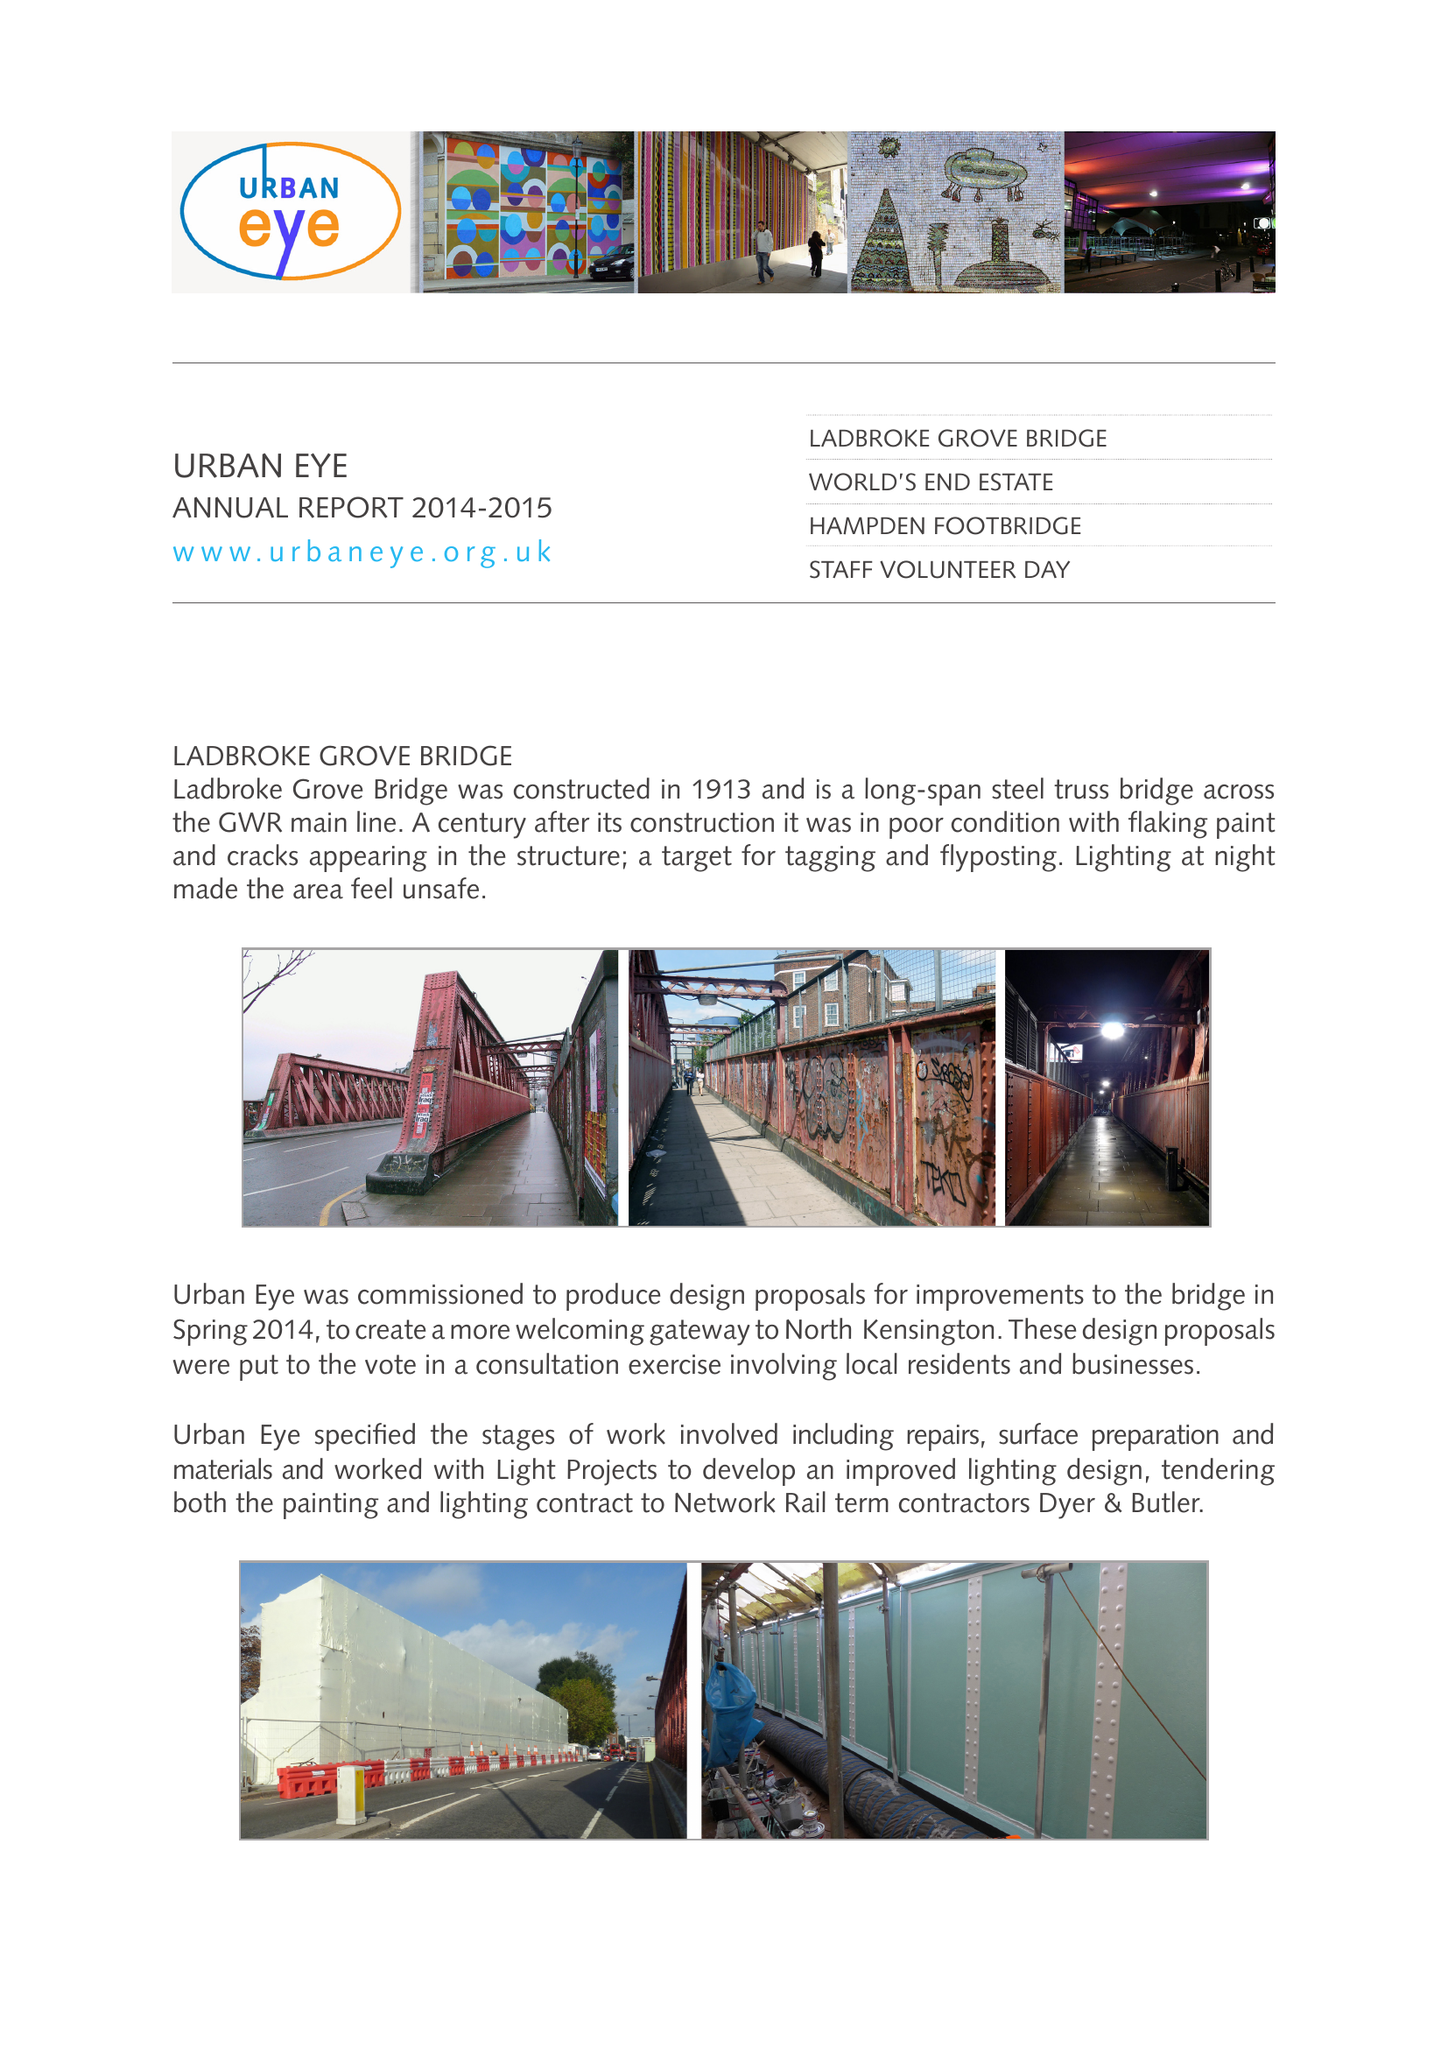What is the value for the address__post_town?
Answer the question using a single word or phrase. LONDON 